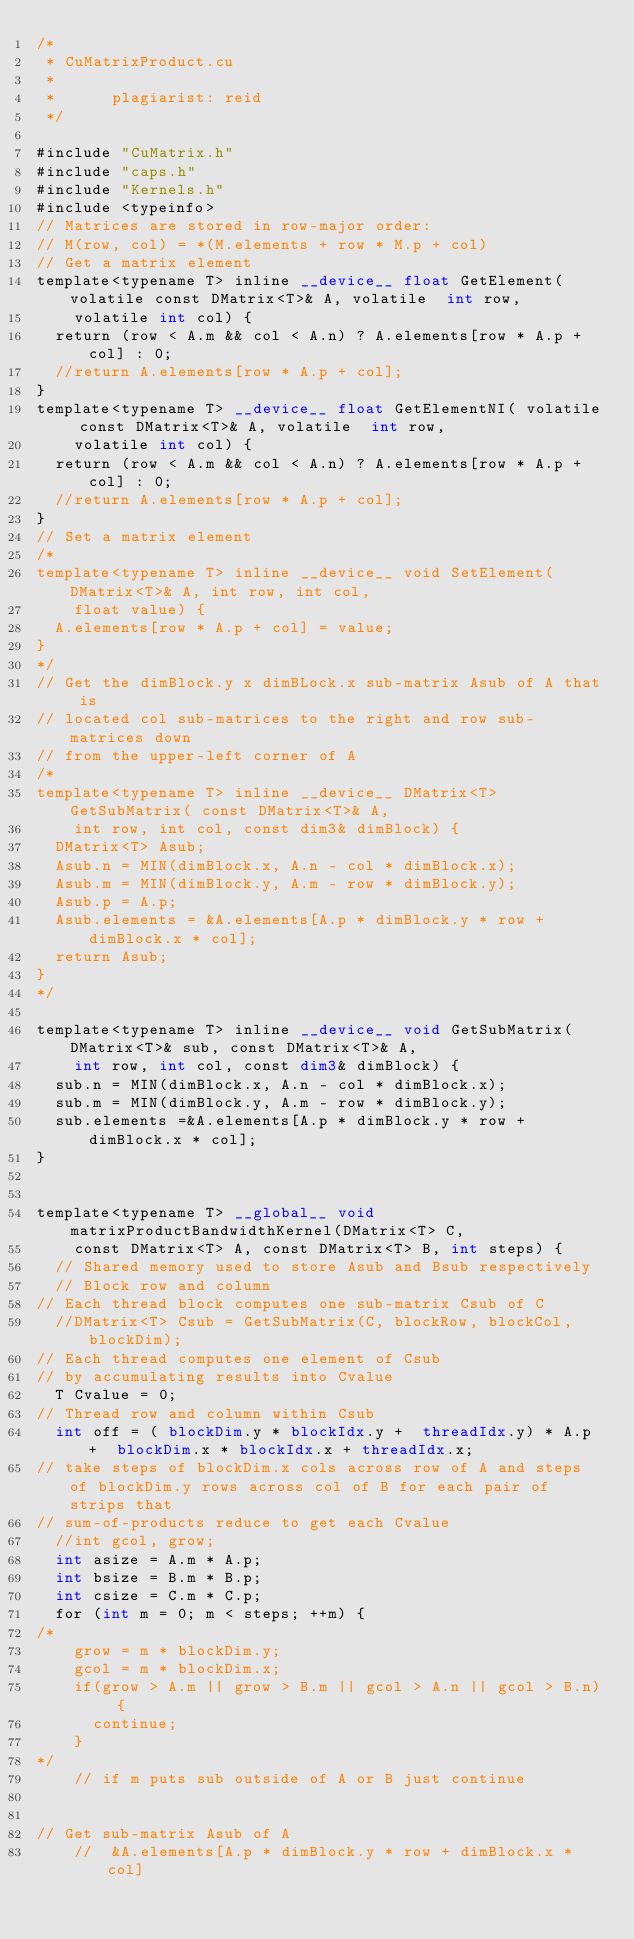Convert code to text. <code><loc_0><loc_0><loc_500><loc_500><_Cuda_>/*
 * CuMatrixProduct.cu
 *
 *      plagiarist: reid
 */

#include "CuMatrix.h"
#include "caps.h"
#include "Kernels.h"
#include <typeinfo>
// Matrices are stored in row-major order:
// M(row, col) = *(M.elements + row * M.p + col)
// Get a matrix element
template<typename T> inline __device__ float GetElement( volatile const DMatrix<T>& A, volatile  int row,
		volatile int col) {
	return (row < A.m && col < A.n) ? A.elements[row * A.p + col] : 0;
	//return A.elements[row * A.p + col];
}
template<typename T> __device__ float GetElementNI( volatile const DMatrix<T>& A, volatile  int row,
		volatile int col) {
	return (row < A.m && col < A.n) ? A.elements[row * A.p + col] : 0;
	//return A.elements[row * A.p + col];
}
// Set a matrix element
/*
template<typename T> inline __device__ void SetElement(DMatrix<T>& A, int row, int col,
		float value) {
	A.elements[row * A.p + col] = value;
}
*/
// Get the dimBlock.y x dimBLock.x sub-matrix Asub of A that is
// located col sub-matrices to the right and row sub-matrices down
// from the upper-left corner of A
/*
template<typename T> inline __device__ DMatrix<T> GetSubMatrix( const DMatrix<T>& A,
		int row, int col, const dim3& dimBlock) {
	DMatrix<T> Asub;
	Asub.n = MIN(dimBlock.x, A.n - col * dimBlock.x);
	Asub.m = MIN(dimBlock.y, A.m - row * dimBlock.y);
	Asub.p = A.p;
	Asub.elements = &A.elements[A.p * dimBlock.y * row + dimBlock.x * col];
	return Asub;
}
*/

template<typename T> inline __device__ void GetSubMatrix(DMatrix<T>& sub, const DMatrix<T>& A,
		int row, int col, const dim3& dimBlock) {
	sub.n = MIN(dimBlock.x, A.n - col * dimBlock.x);
	sub.m = MIN(dimBlock.y, A.m - row * dimBlock.y);
	sub.elements =&A.elements[A.p * dimBlock.y * row + dimBlock.x * col];
}


template<typename T> __global__ void matrixProductBandwidthKernel(DMatrix<T> C,
		const DMatrix<T> A, const DMatrix<T> B, int steps) {
	// Shared memory used to store Asub and Bsub respectively
	// Block row and column
// Each thread block computes one sub-matrix Csub of C
	//DMatrix<T> Csub = GetSubMatrix(C, blockRow, blockCol, blockDim);
// Each thread computes one element of Csub
// by accumulating results into Cvalue
	T Cvalue = 0;
// Thread row and column within Csub
	int off = ( blockDim.y * blockIdx.y +  threadIdx.y) * A.p +  blockDim.x * blockIdx.x + threadIdx.x;
// take steps of blockDim.x cols across row of A and steps of blockDim.y rows across col of B for each pair of strips that
// sum-of-products reduce to get each Cvalue
	//int gcol, grow;
	int asize = A.m * A.p;
	int bsize = B.m * B.p;
	int csize = C.m * C.p;
	for (int m = 0; m < steps; ++m) {
/*
		grow = m * blockDim.y;
		gcol = m * blockDim.x;
		if(grow > A.m || grow > B.m || gcol > A.n || gcol > B.n) {
			continue;
		}
*/
		// if m puts sub outside of A or B just continue


// Get sub-matrix Asub of A
		//  &A.elements[A.p * dimBlock.y * row + dimBlock.x * col]</code> 